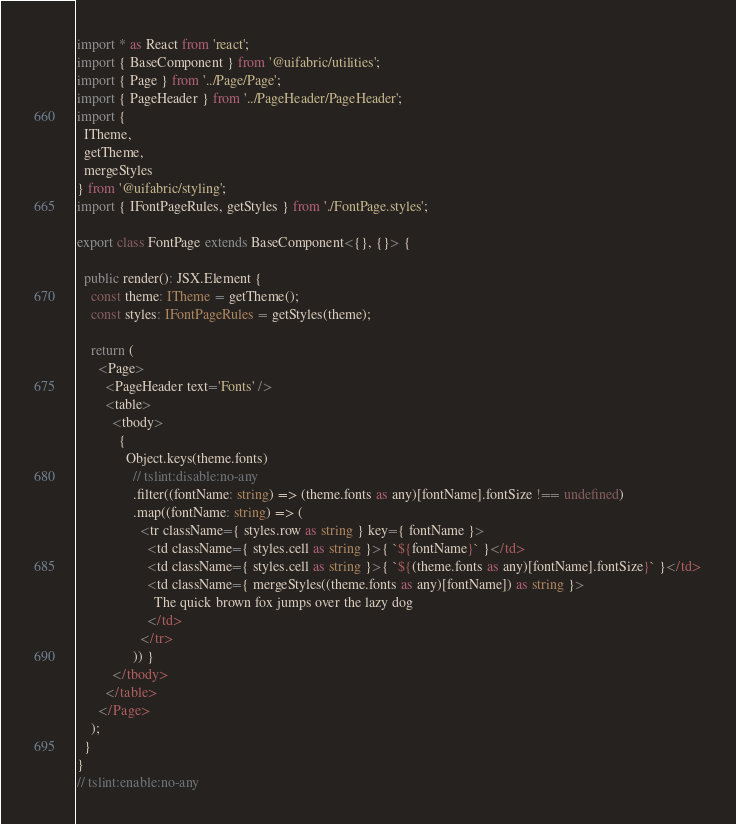<code> <loc_0><loc_0><loc_500><loc_500><_TypeScript_>import * as React from 'react';
import { BaseComponent } from '@uifabric/utilities';
import { Page } from '../Page/Page';
import { PageHeader } from '../PageHeader/PageHeader';
import {
  ITheme,
  getTheme,
  mergeStyles
} from '@uifabric/styling';
import { IFontPageRules, getStyles } from './FontPage.styles';

export class FontPage extends BaseComponent<{}, {}> {

  public render(): JSX.Element {
    const theme: ITheme = getTheme();
    const styles: IFontPageRules = getStyles(theme);

    return (
      <Page>
        <PageHeader text='Fonts' />
        <table>
          <tbody>
            {
              Object.keys(theme.fonts)
                // tslint:disable:no-any
                .filter((fontName: string) => (theme.fonts as any)[fontName].fontSize !== undefined)
                .map((fontName: string) => (
                  <tr className={ styles.row as string } key={ fontName }>
                    <td className={ styles.cell as string }>{ `${fontName}` }</td>
                    <td className={ styles.cell as string }>{ `${(theme.fonts as any)[fontName].fontSize}` }</td>
                    <td className={ mergeStyles((theme.fonts as any)[fontName]) as string }>
                      The quick brown fox jumps over the lazy dog
                    </td>
                  </tr>
                )) }
          </tbody>
        </table>
      </Page>
    );
  }
}
// tslint:enable:no-any
</code> 